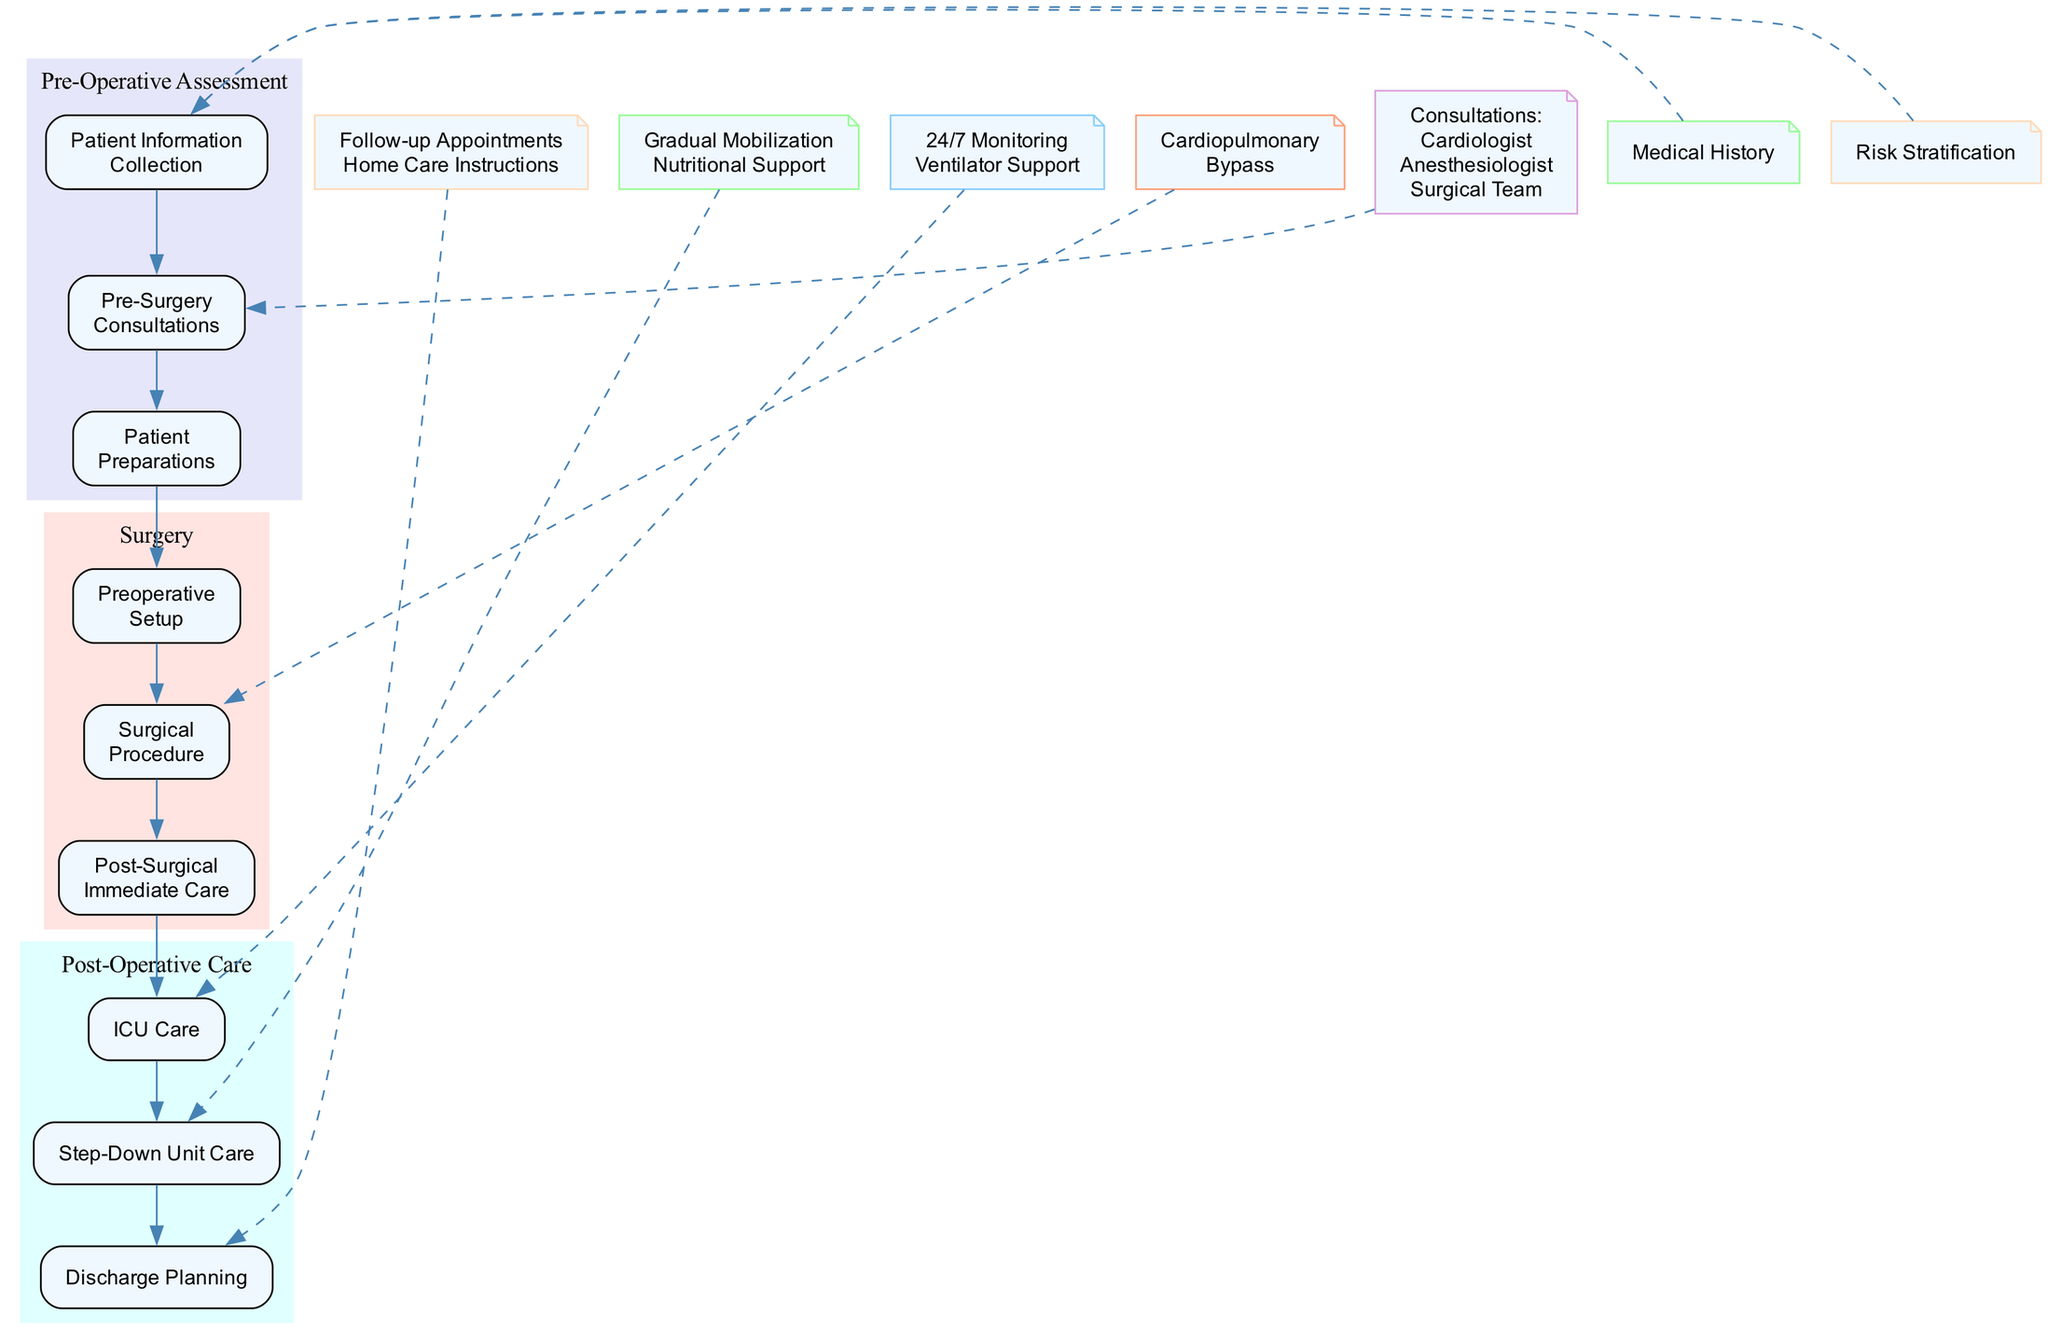What are the three main stages in the patient journey? The diagram displays three main stages: Pre-Operative Assessment, Surgery, and Post-Operative Care. Each stage contains sub-nodes representing specific activities.
Answer: Pre-Operative Assessment, Surgery, Post-Operative Care How many sub-nodes are associated with Post-Operative Care? In the diagram, the Post-Operative Care stage has three sub-nodes: ICU Care, Step-Down Unit Care, and Discharge Planning. Counting these gives a total of three sub-nodes.
Answer: 3 What is the purpose of the Risk Stratification node? The Risk Stratification node is linked to the Patient Information Collection, indicating its role in assessing the patient's risk for surgery using models like EuroSCORE II. It helps inform clinical decisions in the Pre-Operative Assessment stage.
Answer: Assessment Which node directly follows Patient Preparations? The diagram shows that the Patient Preparations node is directly followed by the Preoperative Setup node, indicating the flow from preparing the patient to the surgical setup.
Answer: Preoperative Setup What type of care is emphasized in the Step-Down Unit Care phase? The Step-Down Unit Care phase emphasizes education and counseling for patients on post-surgical care and lifestyle changes. This is important for their recovery after surgery.
Answer: Education And Counseling In what sequence do the Post-Surgical Immediate Care activities occur? The sequence illustrated in the diagram for Post-Surgical Immediate Care begins with ICU Transfer, followed by Hemodynamic Stabilization, and ends with Pain Management. This shows the priority of patient stabilization post-surgery.
Answer: ICU Transfer, Hemodynamic Stabilization, Pain Management How does Continuous Monitoring relate to ICU Care? Continuous Monitoring is a key component under the ICU Care sub-node, which ensures effective and ongoing assessment of vital signs and cardiac function throughout the recovery period in the ICU.
Answer: 24/7 Monitoring What is the focus of Discharge Planning? Discharge Planning focuses on ensuring patients receive comprehensive summaries of care and instructions for home care, which includes follow-up appointments, ensuring a smooth transition from hospital to home.
Answer: Home Care Instructions What is the last activity in the Pre-Operative Assessment stage? The diagram indicates that the last activity in the Pre-Operative Assessment stage is signing the Consent Forms, marking the final administrative step before surgery.
Answer: Consent Forms 